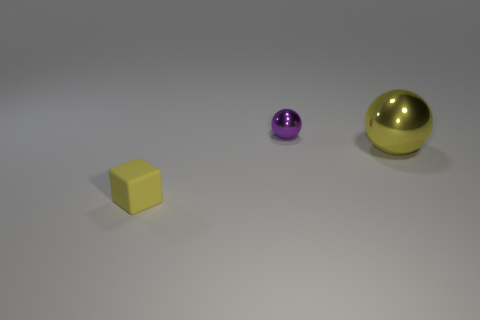Add 1 large balls. How many objects exist? 4 Subtract all blocks. How many objects are left? 2 Add 2 tiny yellow things. How many tiny yellow things are left? 3 Add 2 purple objects. How many purple objects exist? 3 Subtract 0 cyan spheres. How many objects are left? 3 Subtract all tiny yellow matte objects. Subtract all purple metal spheres. How many objects are left? 1 